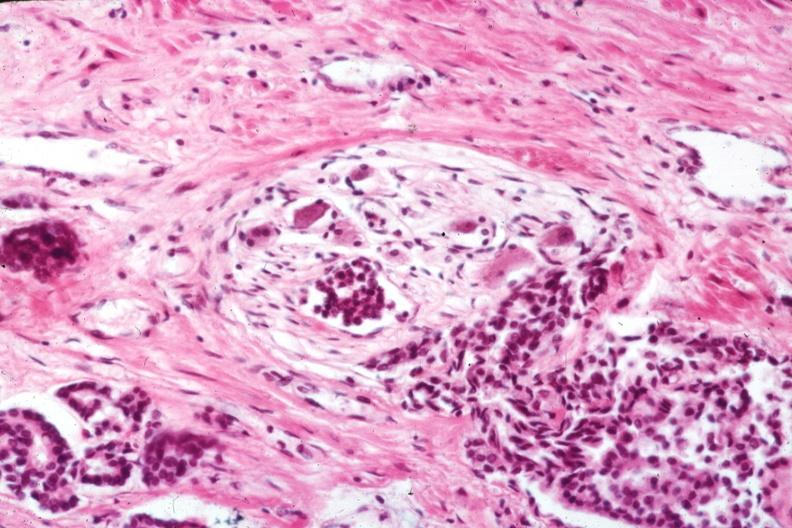does this image show excellent view of perineural invasion typical for this lesion?
Answer the question using a single word or phrase. Yes 